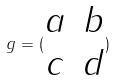Convert formula to latex. <formula><loc_0><loc_0><loc_500><loc_500>g = ( \begin{matrix} a & b \\ c & d \end{matrix} )</formula> 